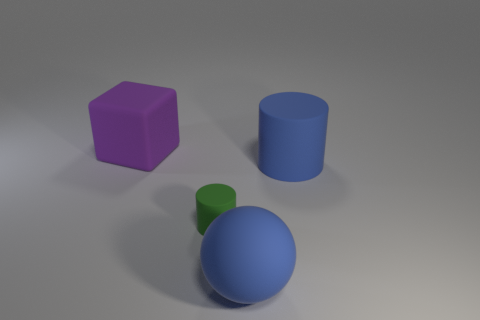Subtract all green cylinders. How many cylinders are left? 1 Add 4 blue matte spheres. How many objects exist? 8 Subtract all cubes. How many objects are left? 3 Subtract 1 purple cubes. How many objects are left? 3 Subtract all large brown shiny cylinders. Subtract all blue rubber cylinders. How many objects are left? 3 Add 4 purple matte cubes. How many purple matte cubes are left? 5 Add 2 large red rubber things. How many large red rubber things exist? 2 